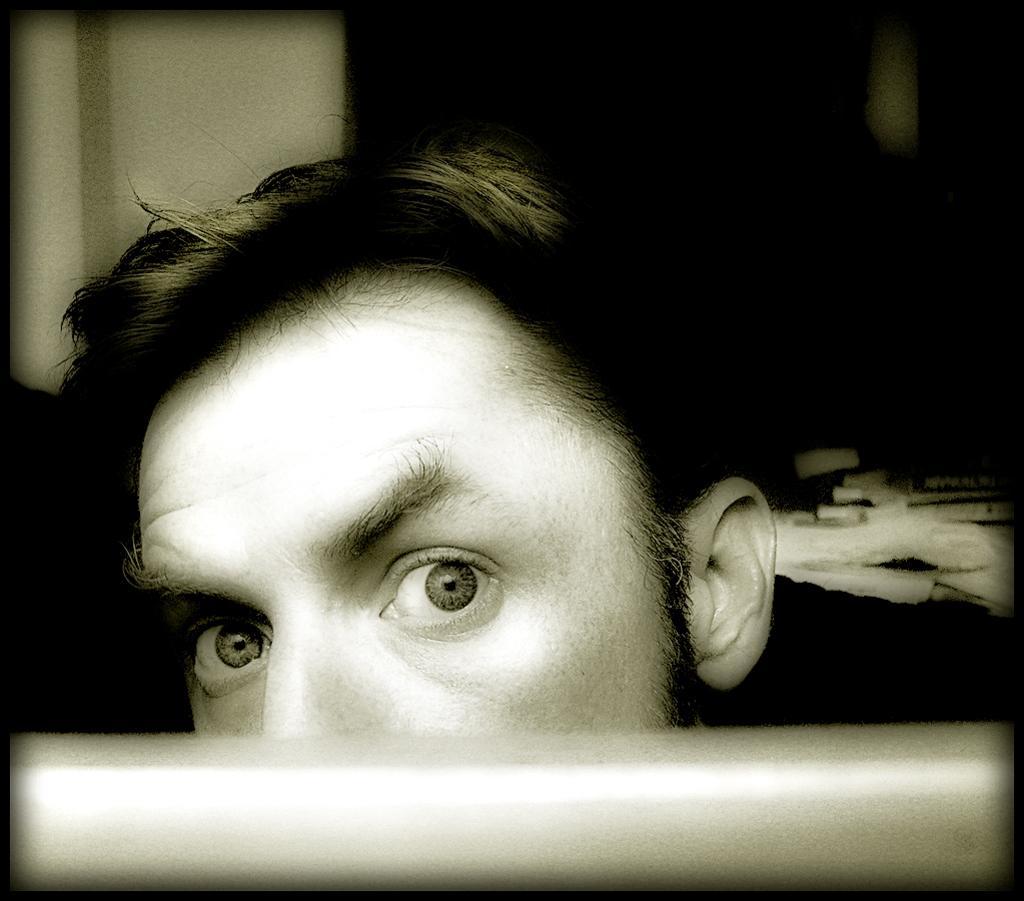What is the color scheme of the image? The image is black and white. What is the main subject of the image? There is a human head in the image. Can you describe the background of the image? The background behind the human head is blurred. What type of flame can be seen coming from the human head in the image? There is no flame present in the image; it is a black and white image of a human head with a blurred background. 